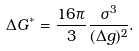Convert formula to latex. <formula><loc_0><loc_0><loc_500><loc_500>\Delta G ^ { * } = \frac { 1 6 \pi } { 3 } \frac { \sigma ^ { 3 } } { ( \Delta g ) ^ { 2 } } .</formula> 